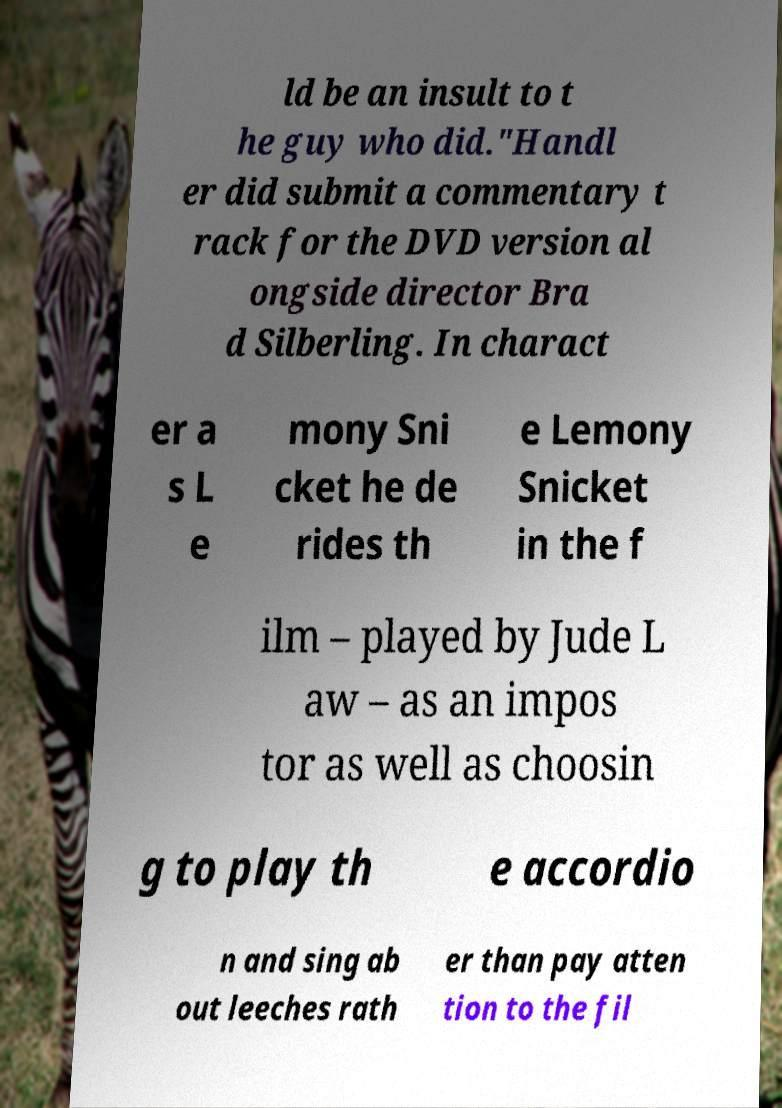Could you assist in decoding the text presented in this image and type it out clearly? ld be an insult to t he guy who did."Handl er did submit a commentary t rack for the DVD version al ongside director Bra d Silberling. In charact er a s L e mony Sni cket he de rides th e Lemony Snicket in the f ilm – played by Jude L aw – as an impos tor as well as choosin g to play th e accordio n and sing ab out leeches rath er than pay atten tion to the fil 